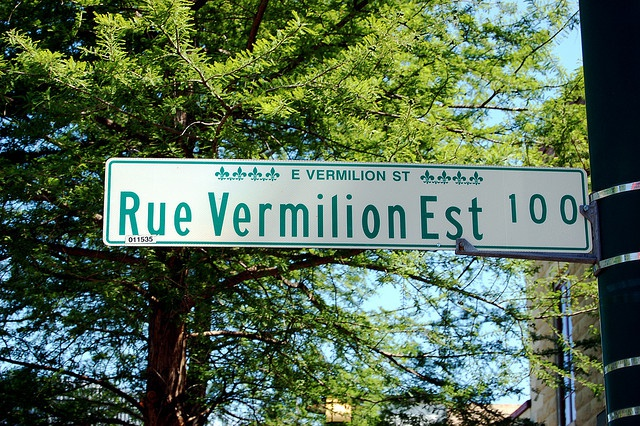Describe the objects in this image and their specific colors. I can see various objects in this image with different colors. 